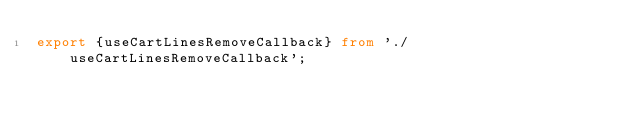Convert code to text. <code><loc_0><loc_0><loc_500><loc_500><_TypeScript_>export {useCartLinesRemoveCallback} from './useCartLinesRemoveCallback';
</code> 